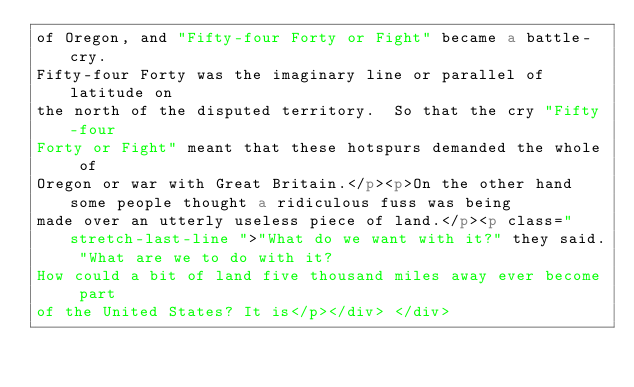<code> <loc_0><loc_0><loc_500><loc_500><_HTML_>of Oregon, and "Fifty-four Forty or Fight" became a battle-cry.
Fifty-four Forty was the imaginary line or parallel of latitude on
the north of the disputed territory.  So that the cry "Fifty-four
Forty or Fight" meant that these hotspurs demanded the whole of
Oregon or war with Great Britain.</p><p>On the other hand some people thought a ridiculous fuss was being
made over an utterly useless piece of land.</p><p class=" stretch-last-line ">"What do we want with it?" they said. "What are we to do with it?
How could a bit of land five thousand miles away ever become part
of the United States? It is</p></div> </div></code> 